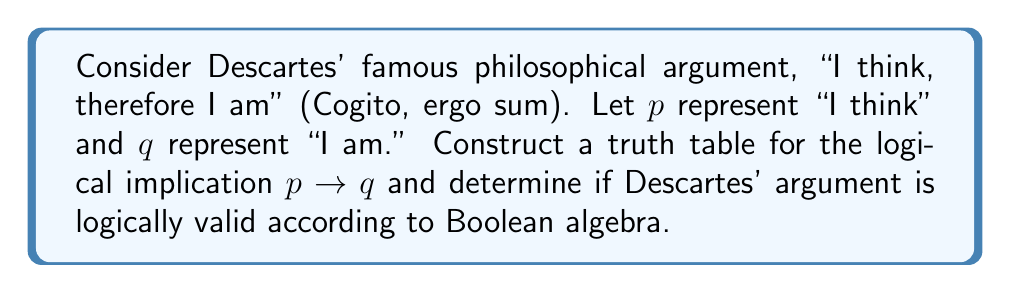Teach me how to tackle this problem. To evaluate Descartes' argument using Boolean algebra, we'll follow these steps:

1. Identify the logical components:
   $p$: "I think"
   $q$: "I am"
   The argument is structured as an implication: $p \rightarrow q$

2. Construct the truth table for $p \rightarrow q$:
   $$
   \begin{array}{|c|c|c|}
   \hline
   p & q & p \rightarrow q \\
   \hline
   T & T & T \\
   T & F & F \\
   F & T & T \\
   F & F & T \\
   \hline
   \end{array}
   $$

3. Interpret the truth table:
   - The implication $p \rightarrow q$ is false only when $p$ is true and $q$ is false.
   - In all other cases, including when $p$ is false, the implication is considered true.

4. Analyze Descartes' argument:
   - Descartes asserts that thinking implies existence.
   - In the context of the truth table, this means that the case where $p$ is true and $q$ is false (second row) should not occur.
   - The truth table shows that the implication is indeed false in this case, which aligns with Descartes' reasoning.

5. Evaluate logical validity:
   - An argument is considered logically valid if it's impossible for the premises to be true and the conclusion false.
   - In this case, the only situation where the implication is false (T → F) is precisely the scenario Descartes argues cannot occur.
   - Therefore, Descartes' argument is logically valid according to Boolean algebra.
Answer: Logically valid 